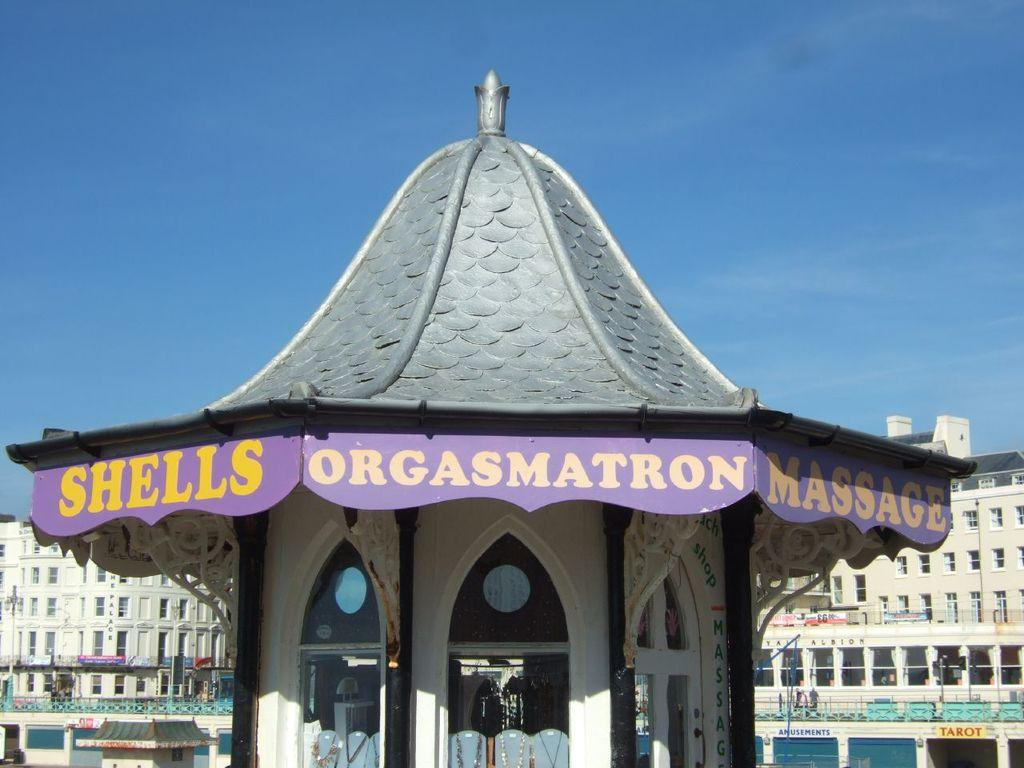What type of establishment is shown in the image? There is a store in the image. What can be seen in the distance behind the store? There are buildings in the background of the image. What is attached to the buildings in the background? There are boards attached to the buildings in the background. What else can be seen in the image besides the store and buildings? There are vehicles visible in the image. What is the color of the sky in the image? The sky is blue in color. What type of oatmeal is being served in the store in the image? There is no indication of oatmeal being served or present in the image. 